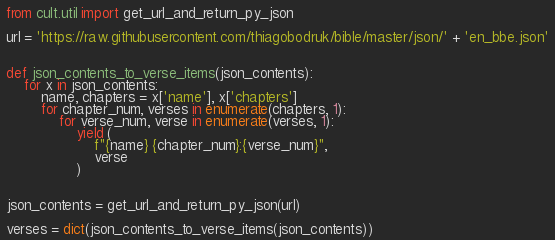Convert code to text. <code><loc_0><loc_0><loc_500><loc_500><_Python_>from cult.util import get_url_and_return_py_json

url = 'https://raw.githubusercontent.com/thiagobodruk/bible/master/json/' + 'en_bbe.json'


def json_contents_to_verse_items(json_contents):
    for x in json_contents:
        name, chapters = x['name'], x['chapters']
        for chapter_num, verses in enumerate(chapters, 1):
            for verse_num, verse in enumerate(verses, 1):
                yield (
                    f"{name} {chapter_num}:{verse_num}",
                    verse
                )


json_contents = get_url_and_return_py_json(url)

verses = dict(json_contents_to_verse_items(json_contents))
</code> 